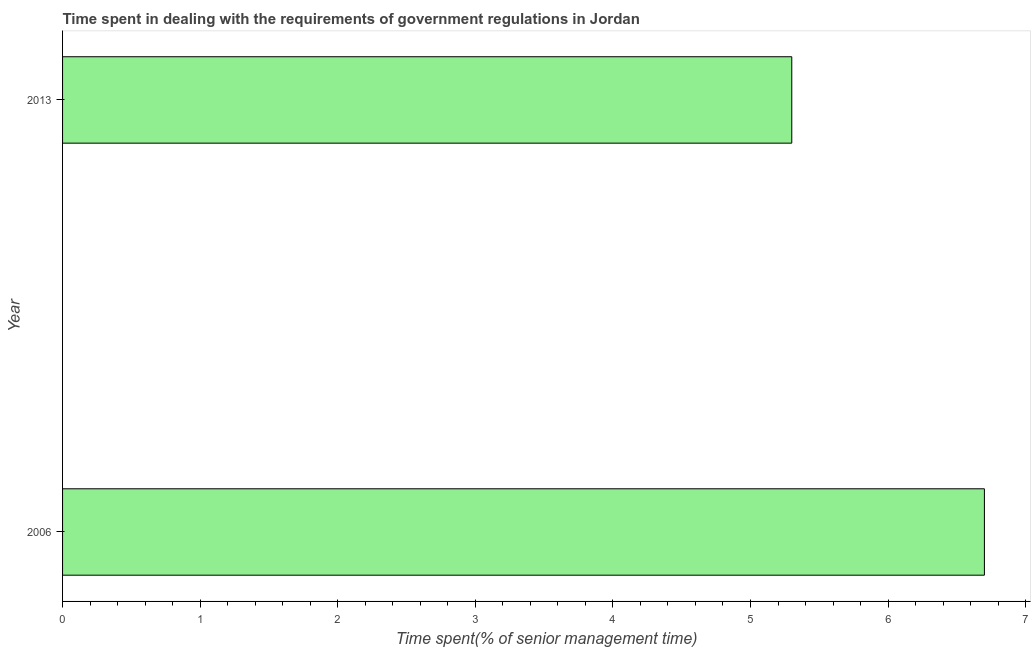What is the title of the graph?
Your response must be concise. Time spent in dealing with the requirements of government regulations in Jordan. What is the label or title of the X-axis?
Offer a terse response. Time spent(% of senior management time). What is the time spent in dealing with government regulations in 2013?
Offer a very short reply. 5.3. Across all years, what is the maximum time spent in dealing with government regulations?
Ensure brevity in your answer.  6.7. Across all years, what is the minimum time spent in dealing with government regulations?
Provide a succinct answer. 5.3. What is the difference between the time spent in dealing with government regulations in 2006 and 2013?
Provide a short and direct response. 1.4. What is the average time spent in dealing with government regulations per year?
Your response must be concise. 6. What is the median time spent in dealing with government regulations?
Your response must be concise. 6. What is the ratio of the time spent in dealing with government regulations in 2006 to that in 2013?
Your answer should be compact. 1.26. Is the time spent in dealing with government regulations in 2006 less than that in 2013?
Offer a terse response. No. What is the Time spent(% of senior management time) in 2006?
Ensure brevity in your answer.  6.7. What is the Time spent(% of senior management time) of 2013?
Your answer should be very brief. 5.3. What is the difference between the Time spent(% of senior management time) in 2006 and 2013?
Your answer should be compact. 1.4. What is the ratio of the Time spent(% of senior management time) in 2006 to that in 2013?
Provide a short and direct response. 1.26. 